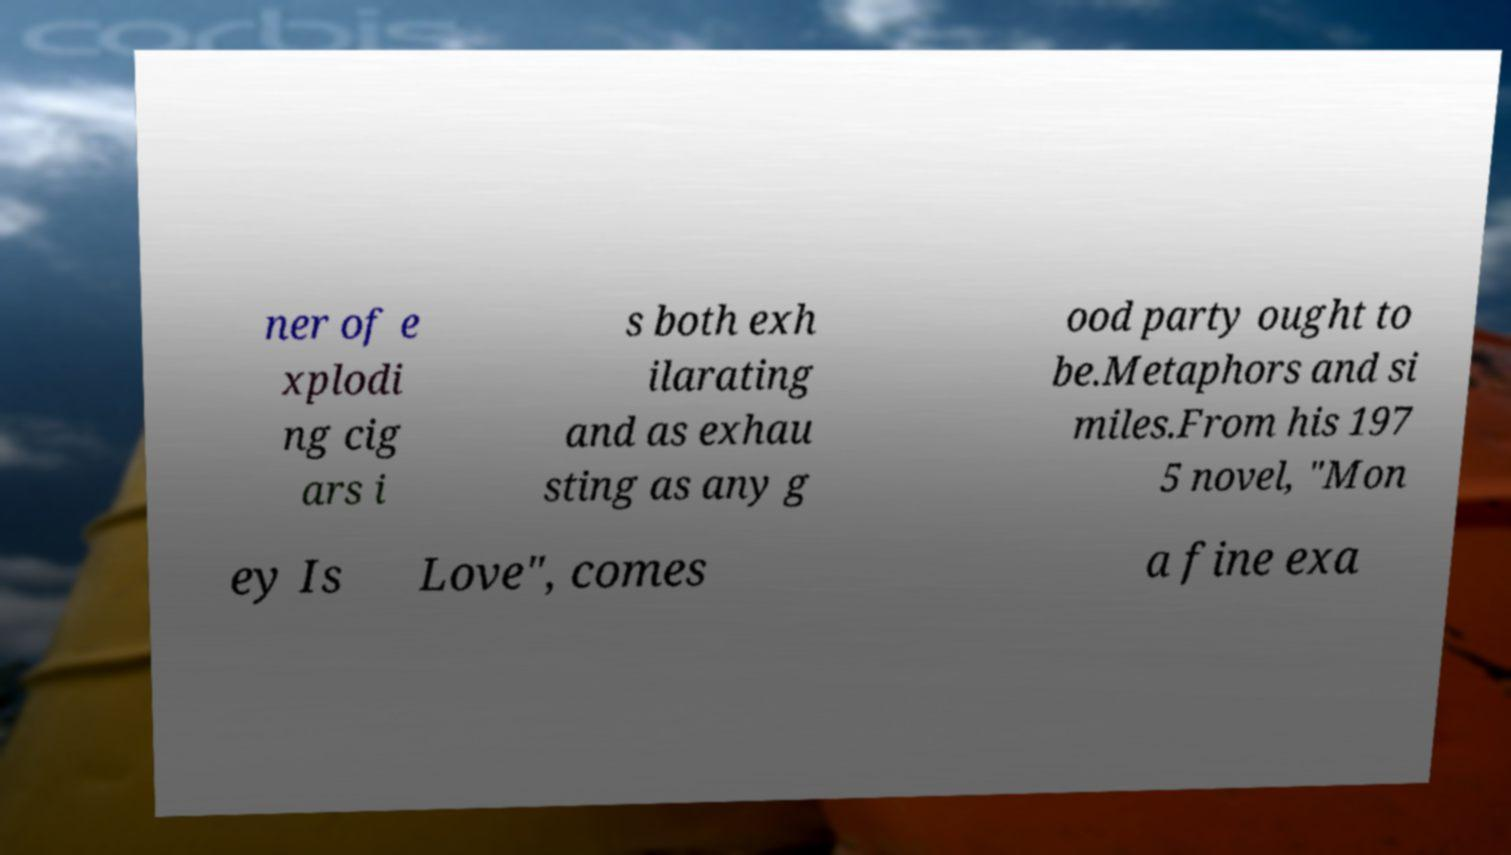Could you extract and type out the text from this image? ner of e xplodi ng cig ars i s both exh ilarating and as exhau sting as any g ood party ought to be.Metaphors and si miles.From his 197 5 novel, "Mon ey Is Love", comes a fine exa 